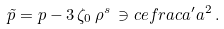<formula> <loc_0><loc_0><loc_500><loc_500>\tilde { p } = p - 3 \, \zeta _ { 0 } \, \rho ^ { s } \, \ni c e f r a c { a ^ { \prime } } { a ^ { 2 } } \, .</formula> 